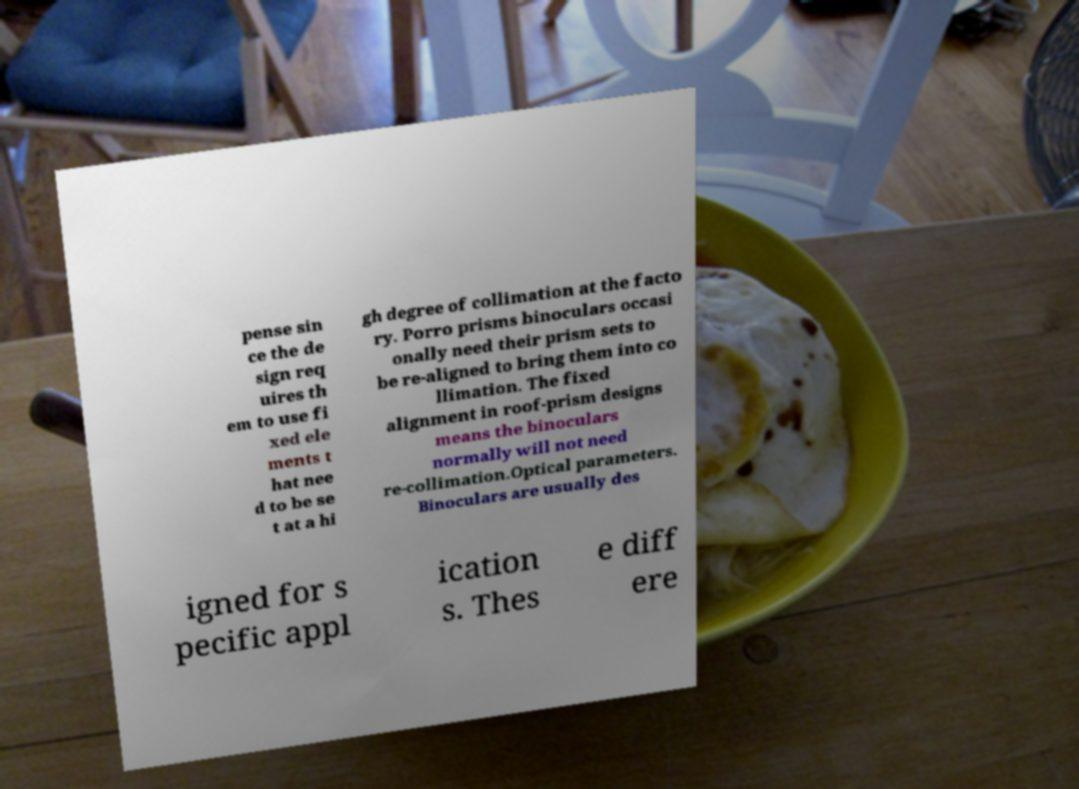I need the written content from this picture converted into text. Can you do that? pense sin ce the de sign req uires th em to use fi xed ele ments t hat nee d to be se t at a hi gh degree of collimation at the facto ry. Porro prisms binoculars occasi onally need their prism sets to be re-aligned to bring them into co llimation. The fixed alignment in roof-prism designs means the binoculars normally will not need re-collimation.Optical parameters. Binoculars are usually des igned for s pecific appl ication s. Thes e diff ere 